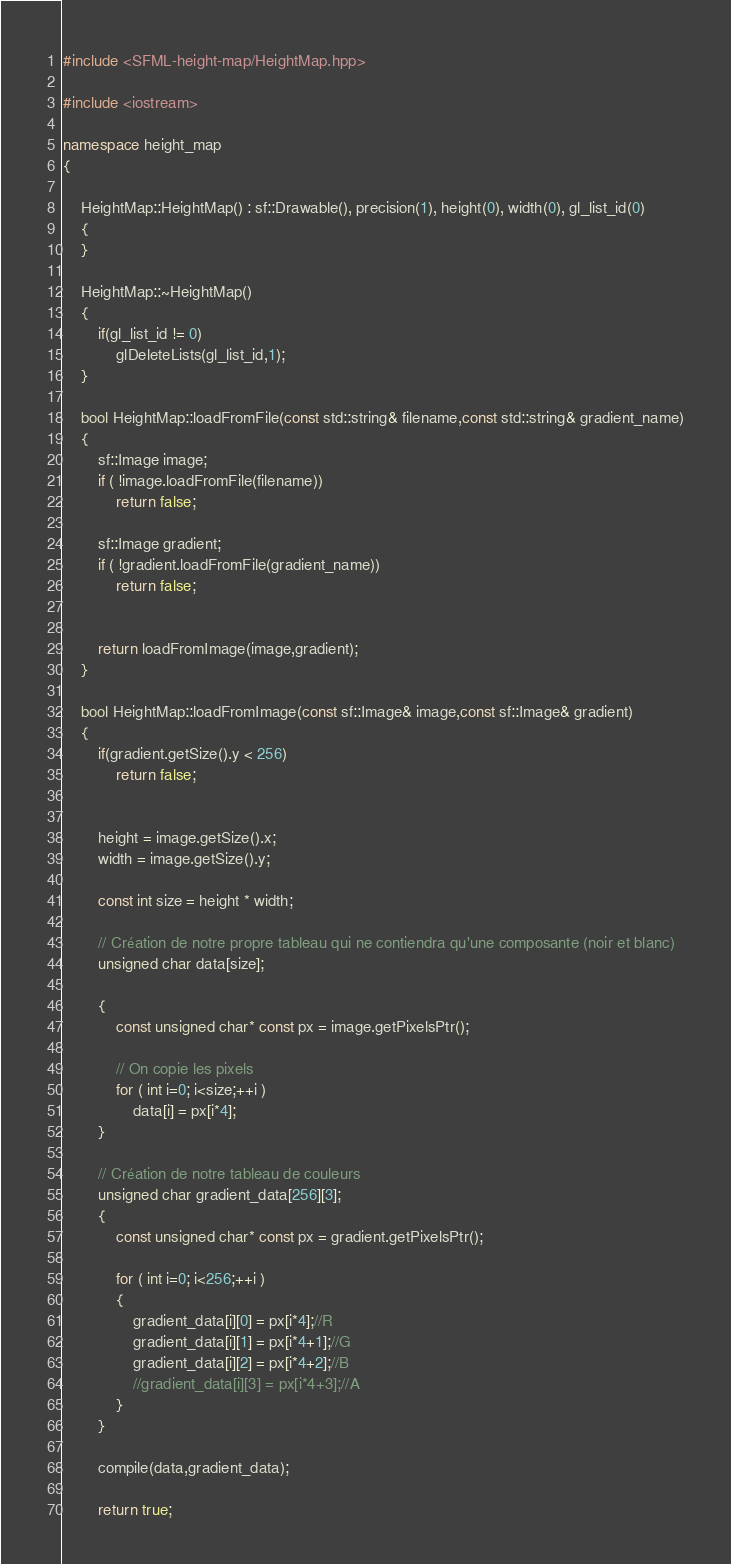<code> <loc_0><loc_0><loc_500><loc_500><_C++_>#include <SFML-height-map/HeightMap.hpp>

#include <iostream>

namespace height_map
{

    HeightMap::HeightMap() : sf::Drawable(), precision(1), height(0), width(0), gl_list_id(0)
    {
    }

    HeightMap::~HeightMap()
    {
        if(gl_list_id != 0)
            glDeleteLists(gl_list_id,1);
    }

    bool HeightMap::loadFromFile(const std::string& filename,const std::string& gradient_name)
    {
        sf::Image image;
        if ( !image.loadFromFile(filename))
            return false;

        sf::Image gradient;
        if ( !gradient.loadFromFile(gradient_name))
            return false;


        return loadFromImage(image,gradient);
    }

    bool HeightMap::loadFromImage(const sf::Image& image,const sf::Image& gradient)
    {
        if(gradient.getSize().y < 256)
            return false;


        height = image.getSize().x;
        width = image.getSize().y;

        const int size = height * width;

        // Création de notre propre tableau qui ne contiendra qu'une composante (noir et blanc)
        unsigned char data[size];

        {
            const unsigned char* const px = image.getPixelsPtr();

            // On copie les pixels
            for ( int i=0; i<size;++i )
                data[i] = px[i*4];
        }

        // Création de notre tableau de couleurs
        unsigned char gradient_data[256][3];
        {
            const unsigned char* const px = gradient.getPixelsPtr();

            for ( int i=0; i<256;++i )
            {
                gradient_data[i][0] = px[i*4];//R
                gradient_data[i][1] = px[i*4+1];//G
                gradient_data[i][2] = px[i*4+2];//B
                //gradient_data[i][3] = px[i*4+3];//A
            }
        }

        compile(data,gradient_data);

        return true;</code> 